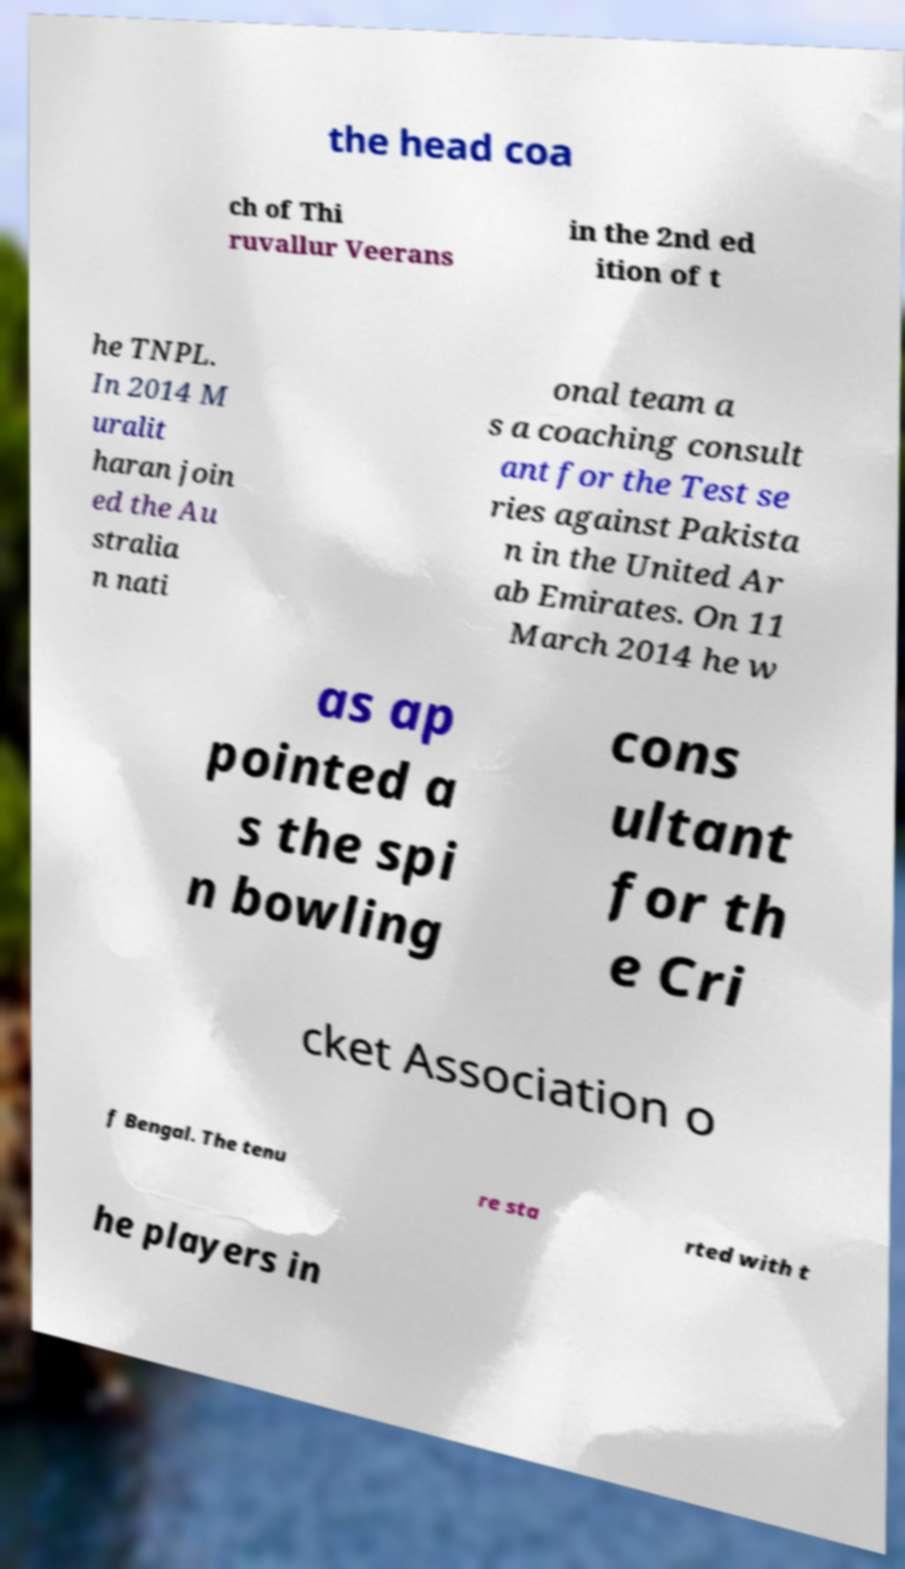Could you assist in decoding the text presented in this image and type it out clearly? the head coa ch of Thi ruvallur Veerans in the 2nd ed ition of t he TNPL. In 2014 M uralit haran join ed the Au stralia n nati onal team a s a coaching consult ant for the Test se ries against Pakista n in the United Ar ab Emirates. On 11 March 2014 he w as ap pointed a s the spi n bowling cons ultant for th e Cri cket Association o f Bengal. The tenu re sta rted with t he players in 